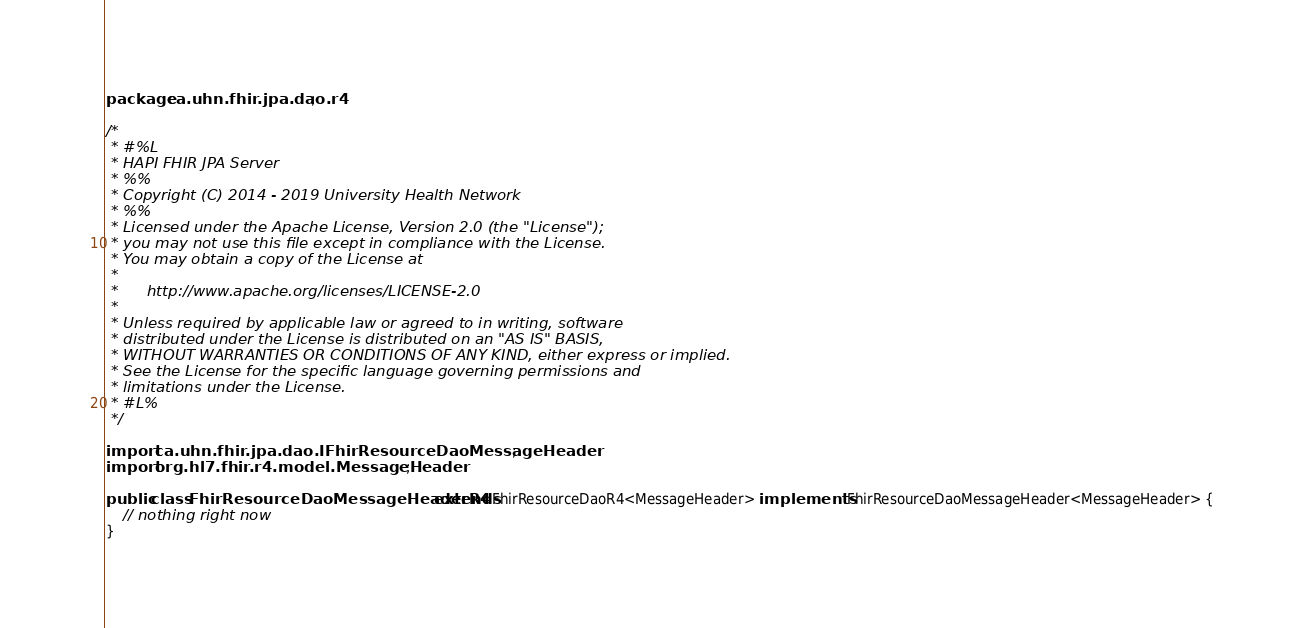Convert code to text. <code><loc_0><loc_0><loc_500><loc_500><_Java_>package ca.uhn.fhir.jpa.dao.r4;

/*
 * #%L
 * HAPI FHIR JPA Server
 * %%
 * Copyright (C) 2014 - 2019 University Health Network
 * %%
 * Licensed under the Apache License, Version 2.0 (the "License");
 * you may not use this file except in compliance with the License.
 * You may obtain a copy of the License at
 *
 *      http://www.apache.org/licenses/LICENSE-2.0
 *
 * Unless required by applicable law or agreed to in writing, software
 * distributed under the License is distributed on an "AS IS" BASIS,
 * WITHOUT WARRANTIES OR CONDITIONS OF ANY KIND, either express or implied.
 * See the License for the specific language governing permissions and
 * limitations under the License.
 * #L%
 */

import ca.uhn.fhir.jpa.dao.IFhirResourceDaoMessageHeader;
import org.hl7.fhir.r4.model.MessageHeader;

public class FhirResourceDaoMessageHeaderR4 extends FhirResourceDaoR4<MessageHeader> implements IFhirResourceDaoMessageHeader<MessageHeader> {
	// nothing right now
}
</code> 